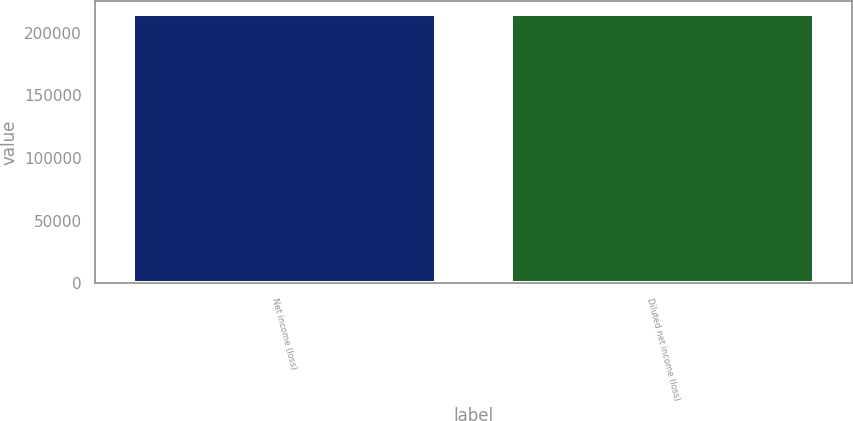<chart> <loc_0><loc_0><loc_500><loc_500><bar_chart><fcel>Net income (loss)<fcel>Diluted net income (loss)<nl><fcel>214769<fcel>214769<nl></chart> 